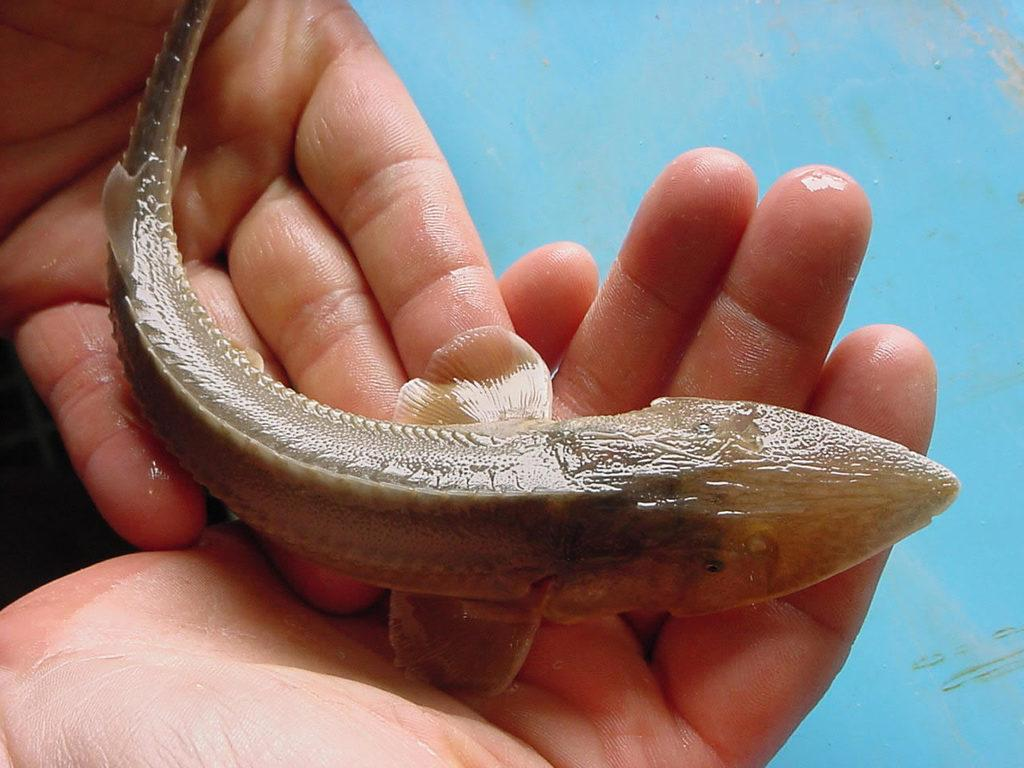What body parts are visible in the image? There are human hands in the image. What is being held by the hands? There is a fish on the hands. Can you describe the fish in the image? The fish is brown in color. What color is the background of the image? The background of the image is blue. What type of popcorn is being served in the image? There is no popcorn present in the image; it features human hands holding a brown fish. How many men are visible in the image? There are no men visible in the image; it only shows human hands holding a fish. 